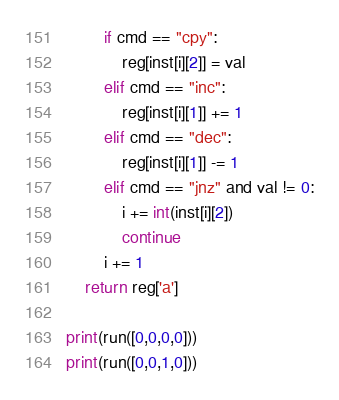Convert code to text. <code><loc_0><loc_0><loc_500><loc_500><_Python_>        if cmd == "cpy":
            reg[inst[i][2]] = val
        elif cmd == "inc":
            reg[inst[i][1]] += 1
        elif cmd == "dec":
            reg[inst[i][1]] -= 1
        elif cmd == "jnz" and val != 0:
            i += int(inst[i][2])
            continue
        i += 1
    return reg['a']

print(run([0,0,0,0]))
print(run([0,0,1,0]))</code> 